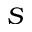<formula> <loc_0><loc_0><loc_500><loc_500>S</formula> 